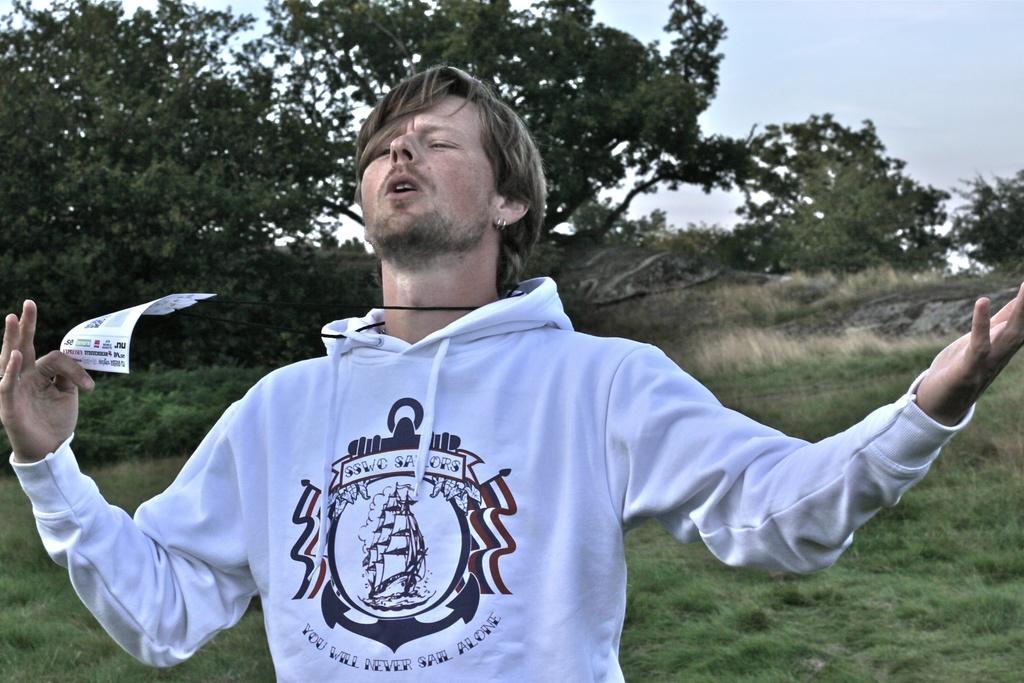How would you summarize this image in a sentence or two? In this image I see a man who is wearing white color hoodie and I see that he is holding a paper in his hand. In the background I see the grass, trees and the sky. 